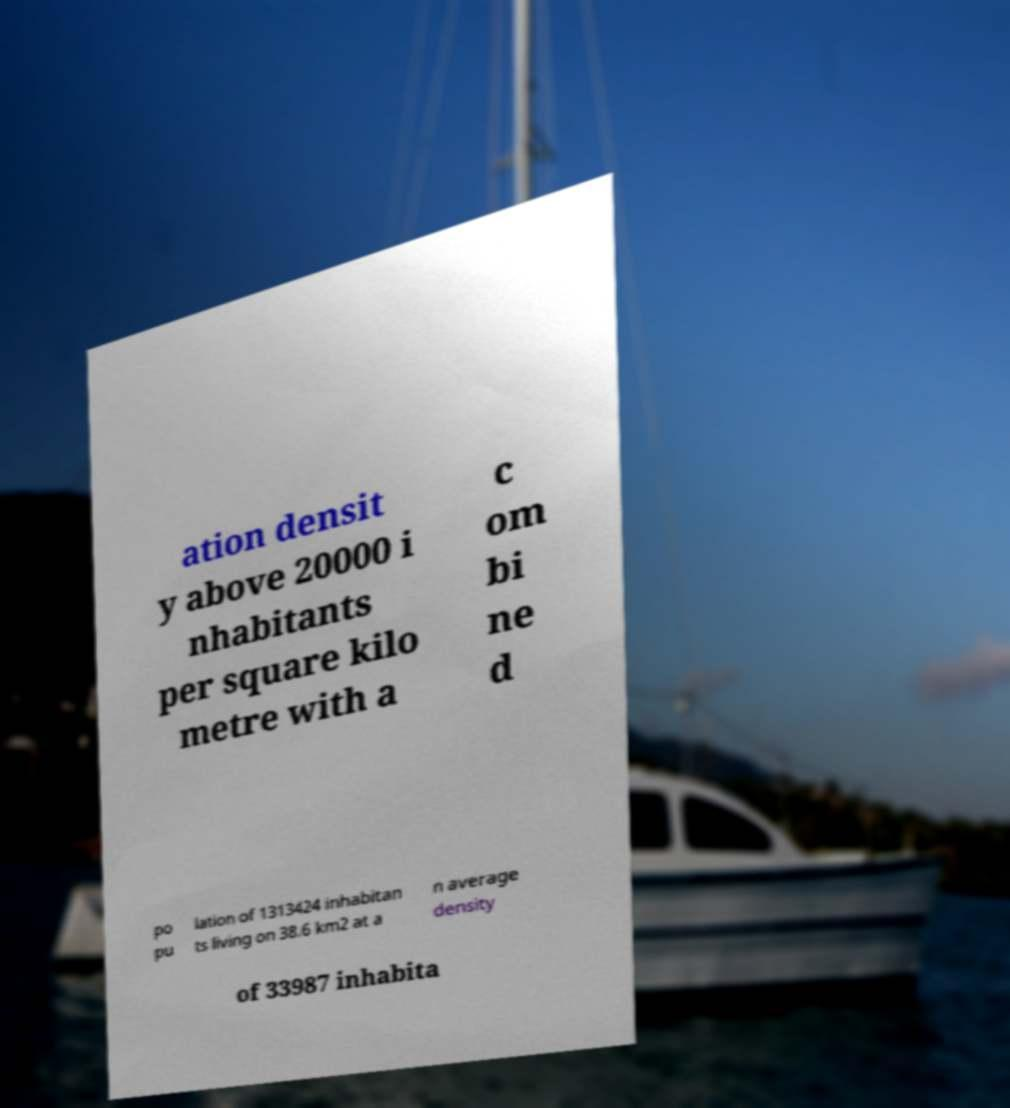What messages or text are displayed in this image? I need them in a readable, typed format. ation densit y above 20000 i nhabitants per square kilo metre with a c om bi ne d po pu lation of 1313424 inhabitan ts living on 38.6 km2 at a n average density of 33987 inhabita 